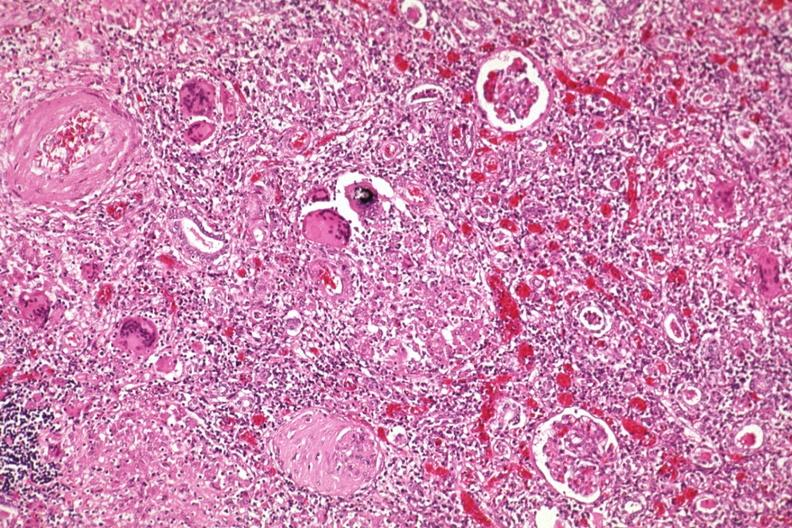what is present?
Answer the question using a single word or phrase. Kidney 